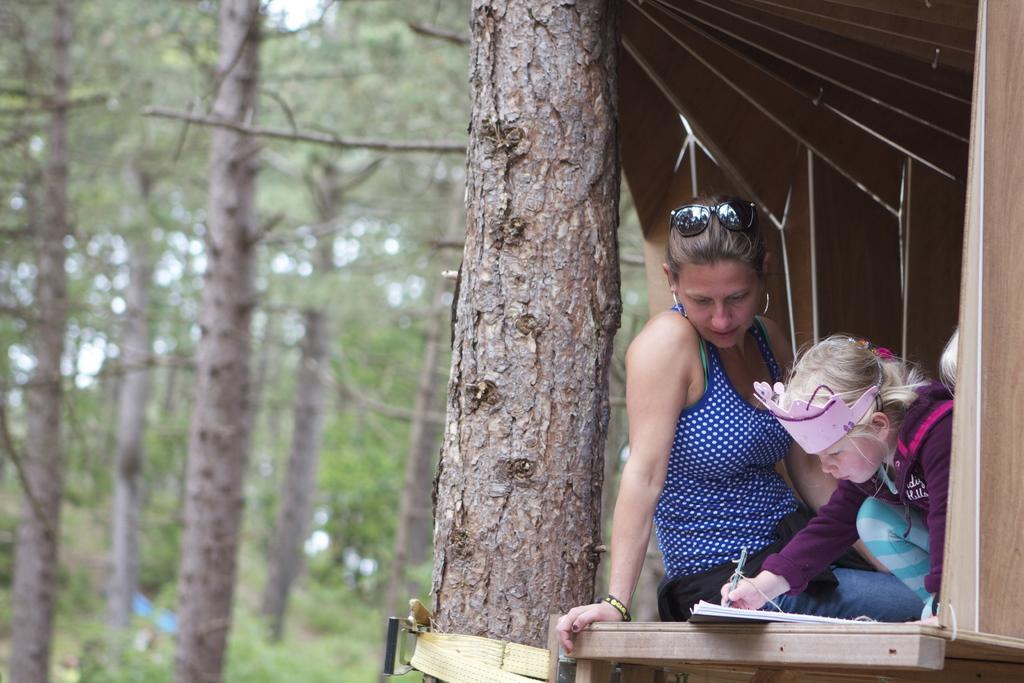Describe this image in one or two sentences. This image consists of a woman and a child. The woman is wearing blue top and blue jeans. Beside her there is a tree. In the background, there are many trees. It looks like it is clicked in a forest. 